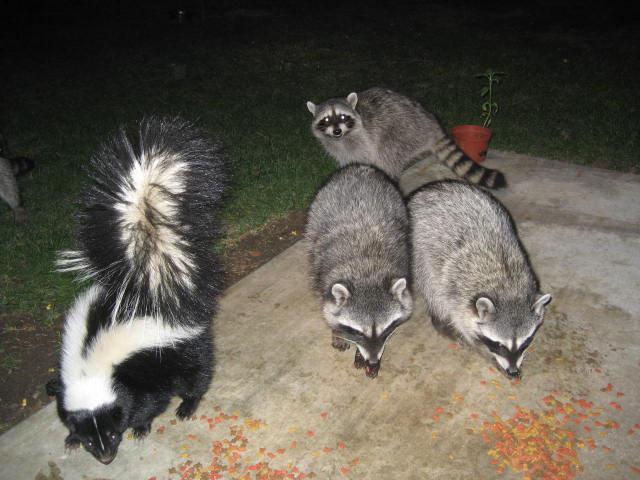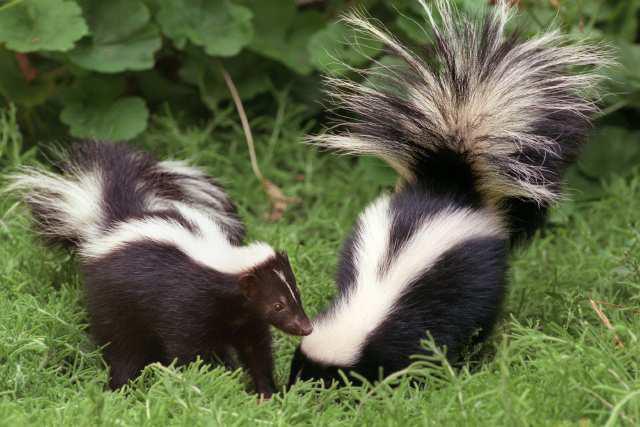The first image is the image on the left, the second image is the image on the right. For the images displayed, is the sentence "There are two parallel skunks with a white vertical stripe on the front of their head." factually correct? Answer yes or no. No. The first image is the image on the left, the second image is the image on the right. Given the left and right images, does the statement "In the left image, exactly one raccoon is standing alongside a skunk that is on all fours with its nose pointed down to a brown surface." hold true? Answer yes or no. No. 